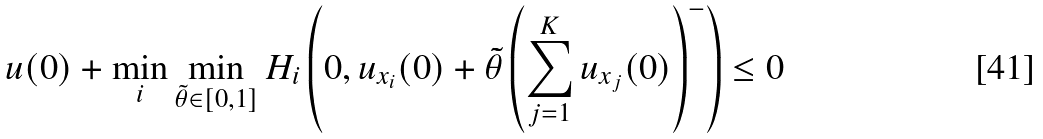Convert formula to latex. <formula><loc_0><loc_0><loc_500><loc_500>u ( 0 ) + \min _ { i } \min _ { \tilde { \theta } \in [ 0 , 1 ] } H _ { i } \left ( 0 , u _ { x _ { i } } ( 0 ) + \tilde { \theta } \left ( \sum _ { j = 1 } ^ { K } u _ { x _ { j } } ( 0 ) \right ) ^ { - } \right ) \leq 0</formula> 